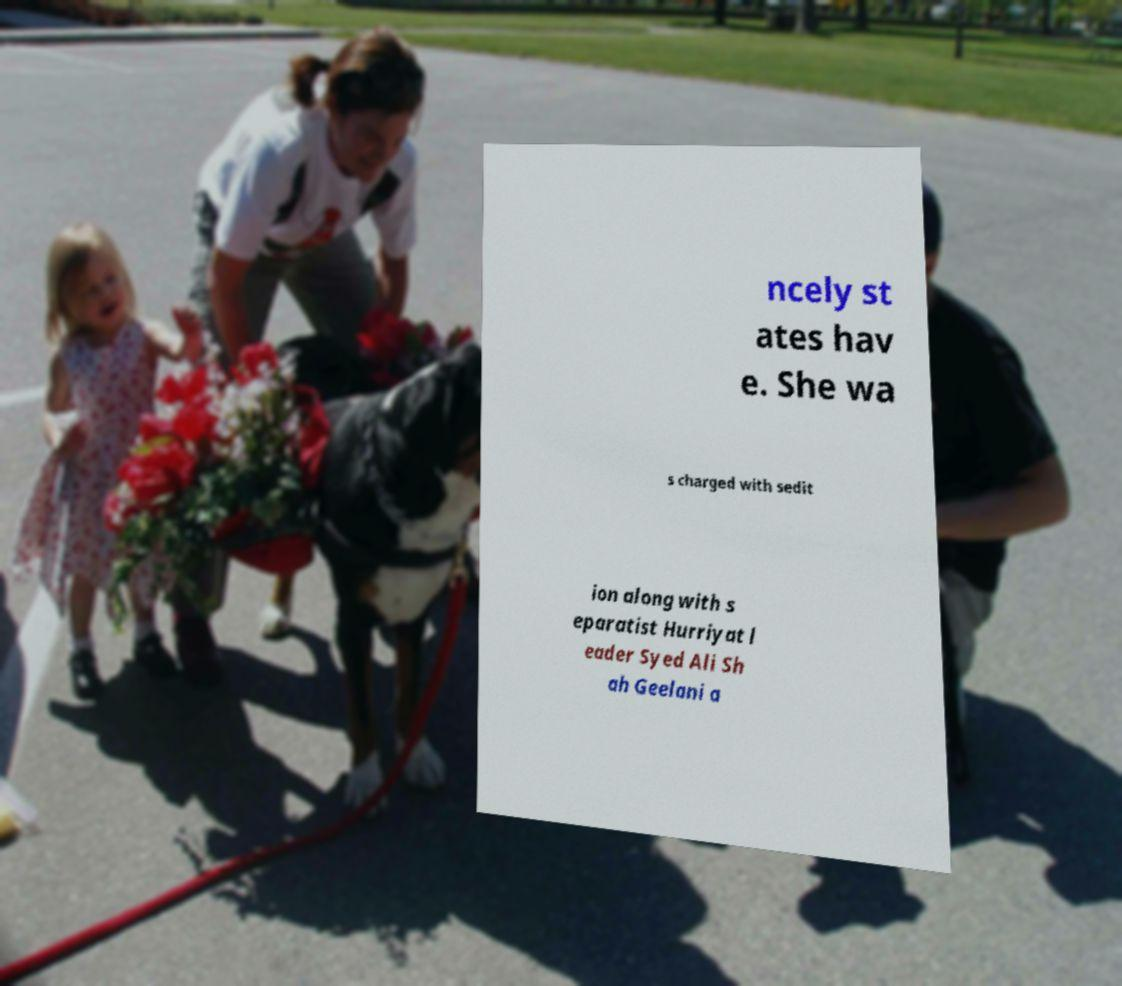I need the written content from this picture converted into text. Can you do that? ncely st ates hav e. She wa s charged with sedit ion along with s eparatist Hurriyat l eader Syed Ali Sh ah Geelani a 